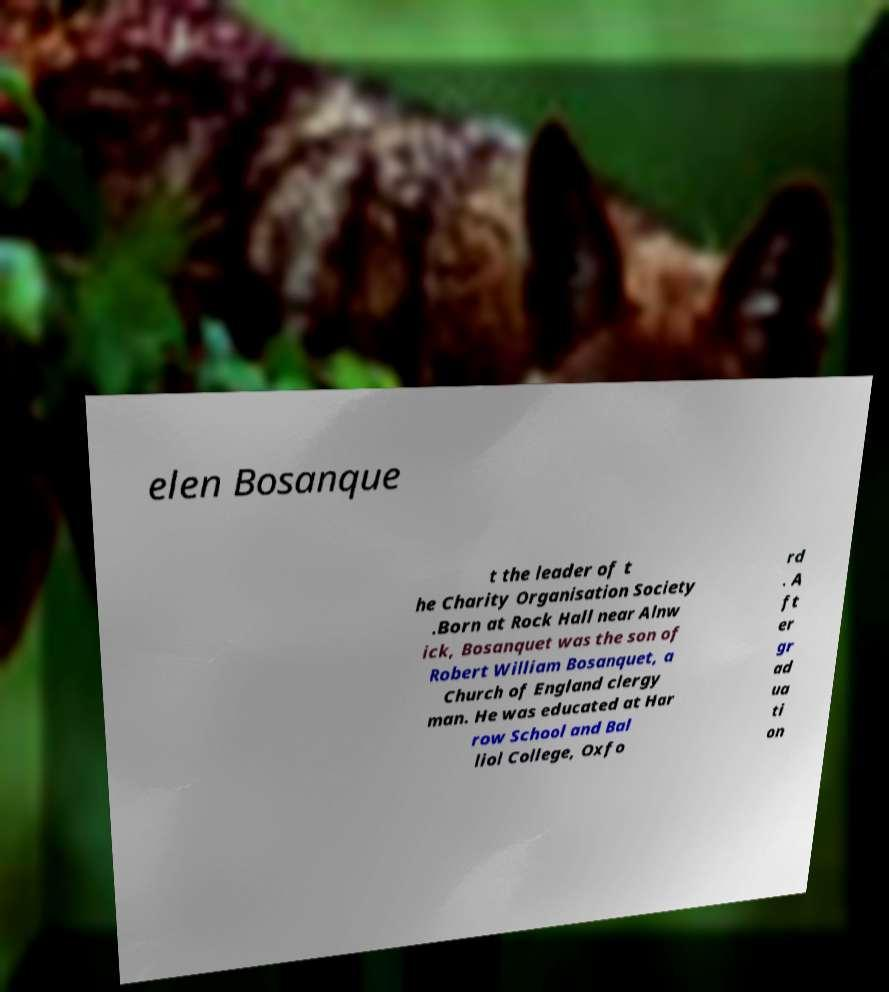For documentation purposes, I need the text within this image transcribed. Could you provide that? elen Bosanque t the leader of t he Charity Organisation Society .Born at Rock Hall near Alnw ick, Bosanquet was the son of Robert William Bosanquet, a Church of England clergy man. He was educated at Har row School and Bal liol College, Oxfo rd . A ft er gr ad ua ti on 